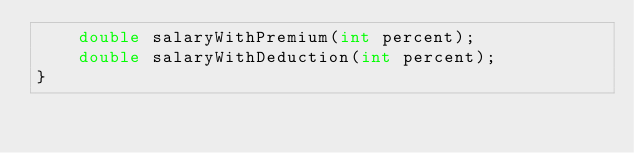Convert code to text. <code><loc_0><loc_0><loc_500><loc_500><_Java_>    double salaryWithPremium(int percent);
    double salaryWithDeduction(int percent);
}
</code> 